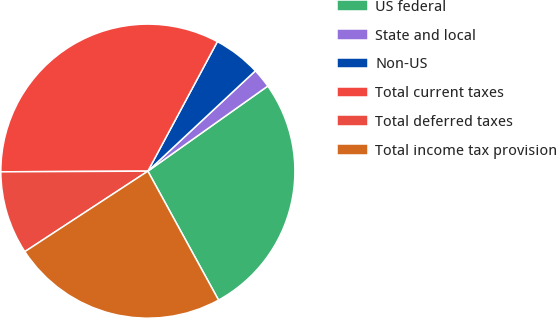Convert chart to OTSL. <chart><loc_0><loc_0><loc_500><loc_500><pie_chart><fcel>US federal<fcel>State and local<fcel>Non-US<fcel>Total current taxes<fcel>Total deferred taxes<fcel>Total income tax provision<nl><fcel>26.84%<fcel>2.13%<fcel>5.21%<fcel>32.91%<fcel>9.15%<fcel>23.76%<nl></chart> 